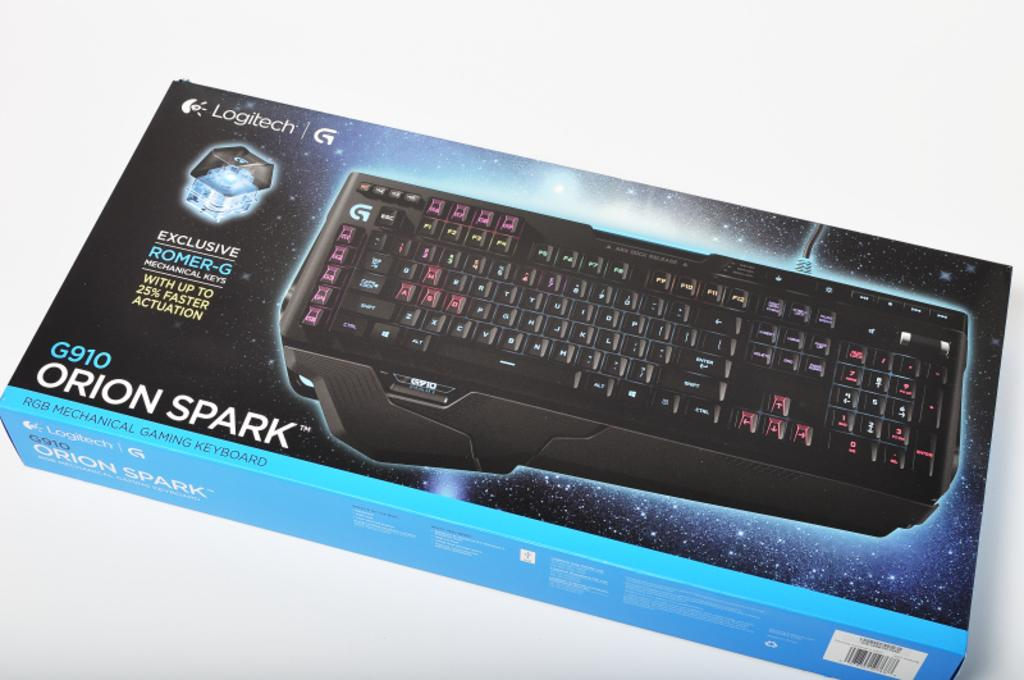<image>
Offer a succinct explanation of the picture presented. Orion Spark G910 black keyboard is made by Logitech. 